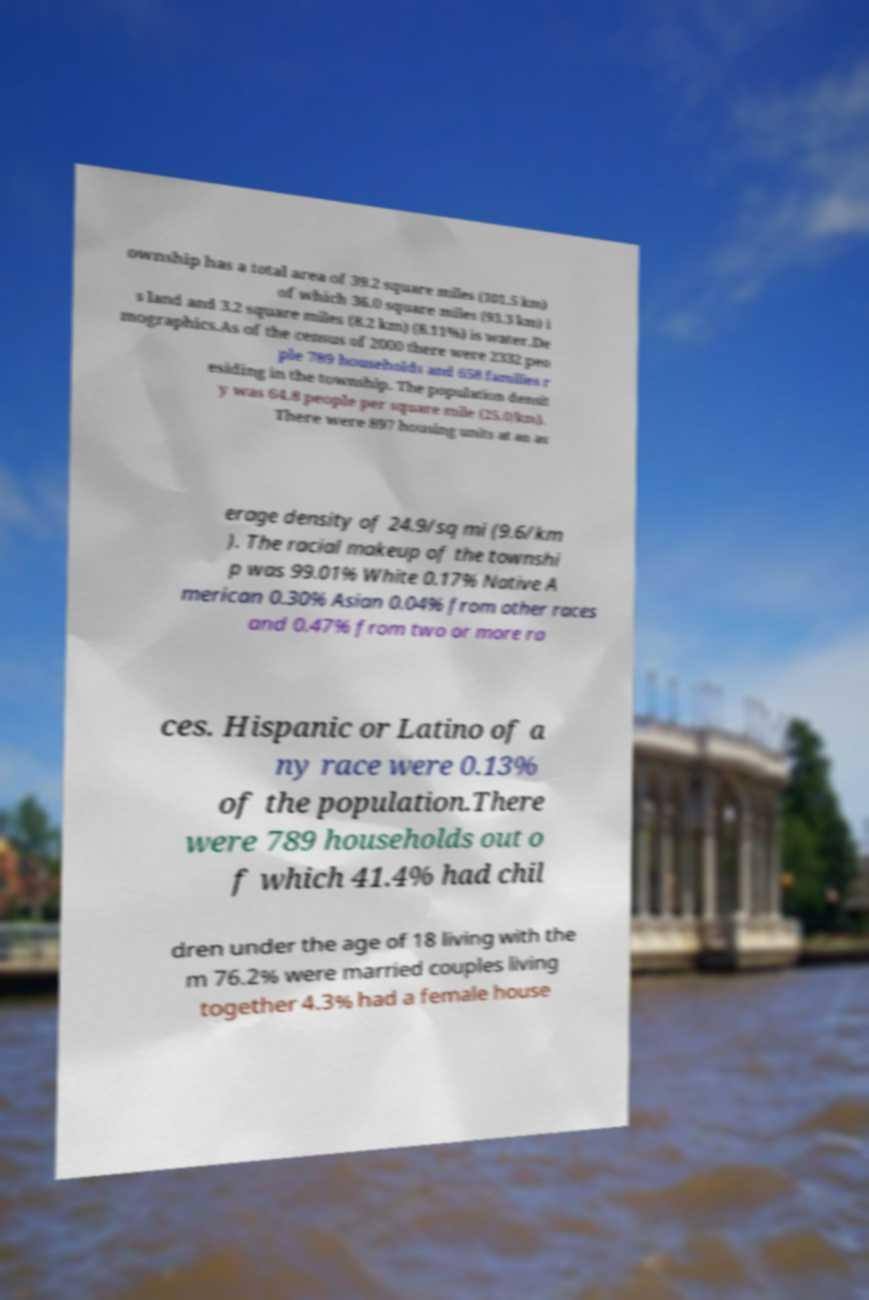For documentation purposes, I need the text within this image transcribed. Could you provide that? ownship has a total area of 39.2 square miles (101.5 km) of which 36.0 square miles (93.3 km) i s land and 3.2 square miles (8.2 km) (8.11%) is water.De mographics.As of the census of 2000 there were 2332 peo ple 789 households and 658 families r esiding in the township. The population densit y was 64.8 people per square mile (25.0/km). There were 897 housing units at an av erage density of 24.9/sq mi (9.6/km ). The racial makeup of the townshi p was 99.01% White 0.17% Native A merican 0.30% Asian 0.04% from other races and 0.47% from two or more ra ces. Hispanic or Latino of a ny race were 0.13% of the population.There were 789 households out o f which 41.4% had chil dren under the age of 18 living with the m 76.2% were married couples living together 4.3% had a female house 